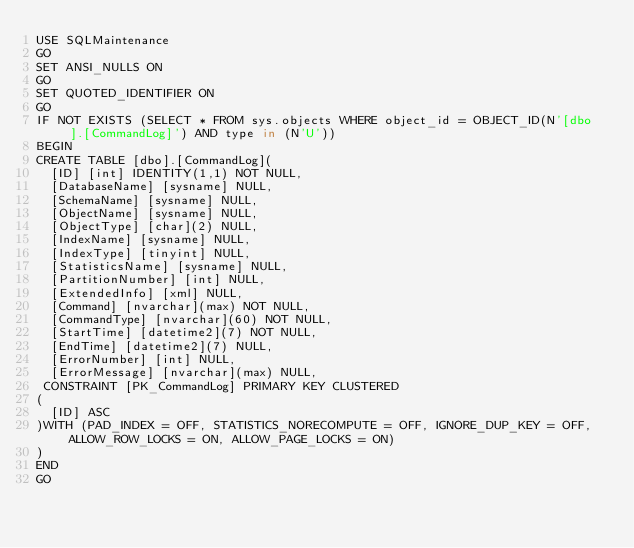<code> <loc_0><loc_0><loc_500><loc_500><_SQL_>USE SQLMaintenance
GO
SET ANSI_NULLS ON
GO
SET QUOTED_IDENTIFIER ON
GO
IF NOT EXISTS (SELECT * FROM sys.objects WHERE object_id = OBJECT_ID(N'[dbo].[CommandLog]') AND type in (N'U'))
BEGIN
CREATE TABLE [dbo].[CommandLog](
  [ID] [int] IDENTITY(1,1) NOT NULL,
  [DatabaseName] [sysname] NULL,
  [SchemaName] [sysname] NULL,
  [ObjectName] [sysname] NULL,
  [ObjectType] [char](2) NULL,
  [IndexName] [sysname] NULL,
  [IndexType] [tinyint] NULL,
  [StatisticsName] [sysname] NULL,
  [PartitionNumber] [int] NULL,
  [ExtendedInfo] [xml] NULL,
  [Command] [nvarchar](max) NOT NULL,
  [CommandType] [nvarchar](60) NOT NULL,
  [StartTime] [datetime2](7) NOT NULL,
  [EndTime] [datetime2](7) NULL,
  [ErrorNumber] [int] NULL,
  [ErrorMessage] [nvarchar](max) NULL,
 CONSTRAINT [PK_CommandLog] PRIMARY KEY CLUSTERED
(
  [ID] ASC
)WITH (PAD_INDEX = OFF, STATISTICS_NORECOMPUTE = OFF, IGNORE_DUP_KEY = OFF, ALLOW_ROW_LOCKS = ON, ALLOW_PAGE_LOCKS = ON)
)
END
GO

</code> 